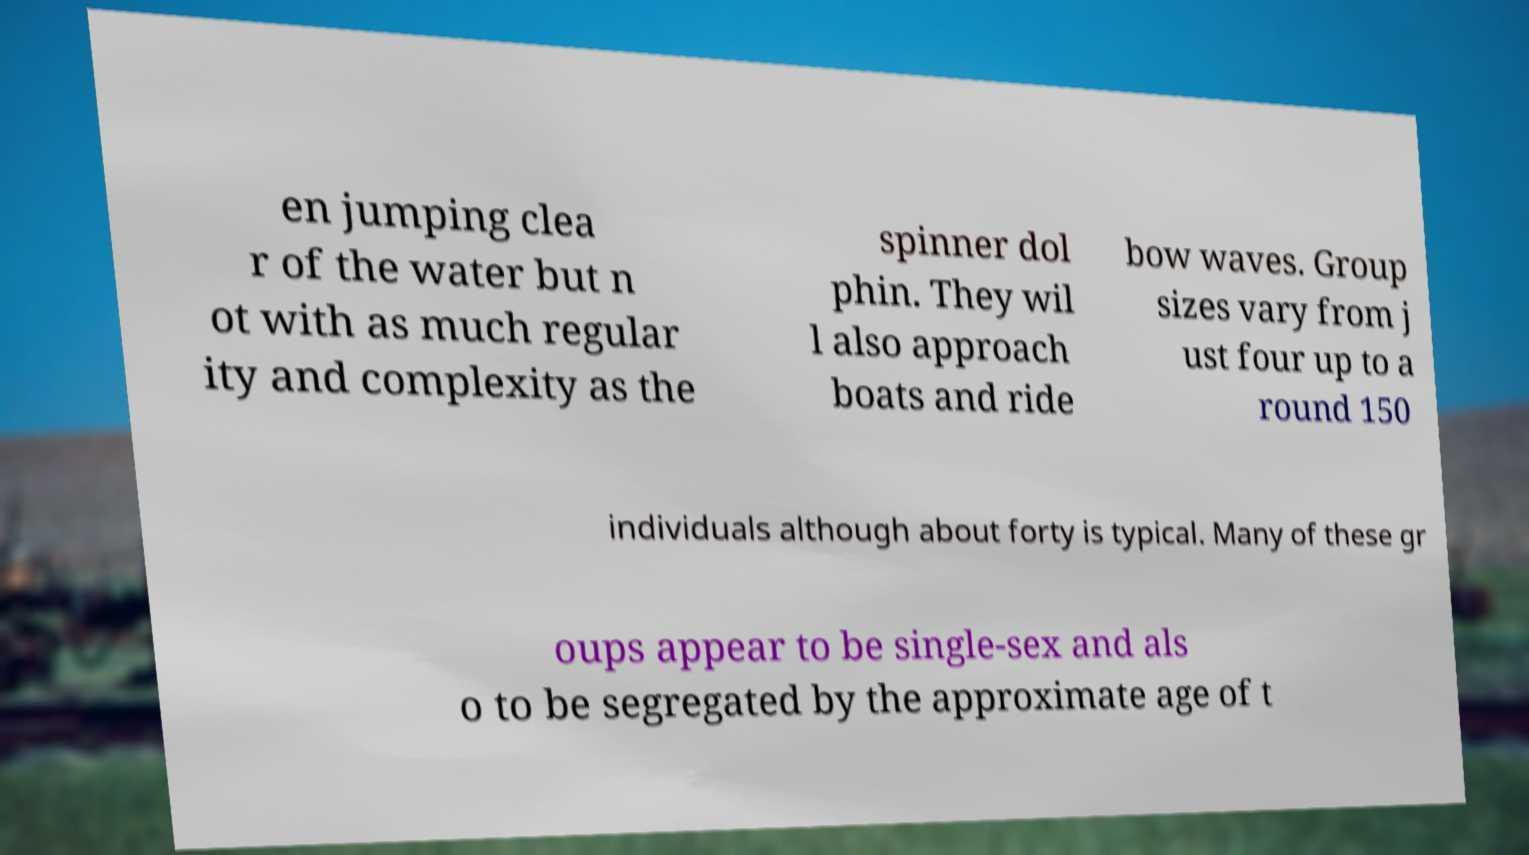Can you accurately transcribe the text from the provided image for me? en jumping clea r of the water but n ot with as much regular ity and complexity as the spinner dol phin. They wil l also approach boats and ride bow waves. Group sizes vary from j ust four up to a round 150 individuals although about forty is typical. Many of these gr oups appear to be single-sex and als o to be segregated by the approximate age of t 